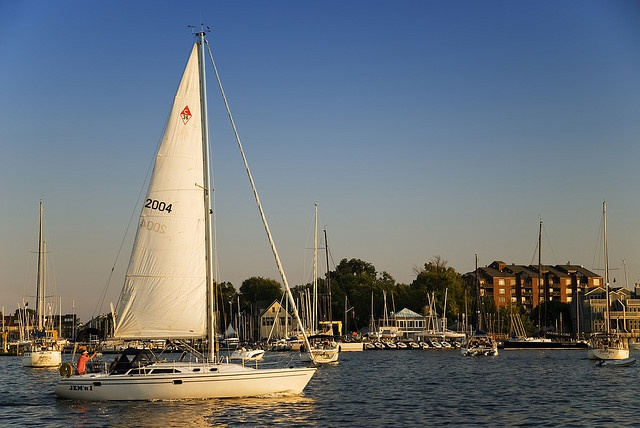Describe the objects in this image and their specific colors. I can see boat in blue, tan, and beige tones, boat in blue, black, gray, and maroon tones, boat in blue, black, tan, khaki, and gray tones, boat in blue, black, gray, and tan tones, and boat in blue, black, gray, and tan tones in this image. 